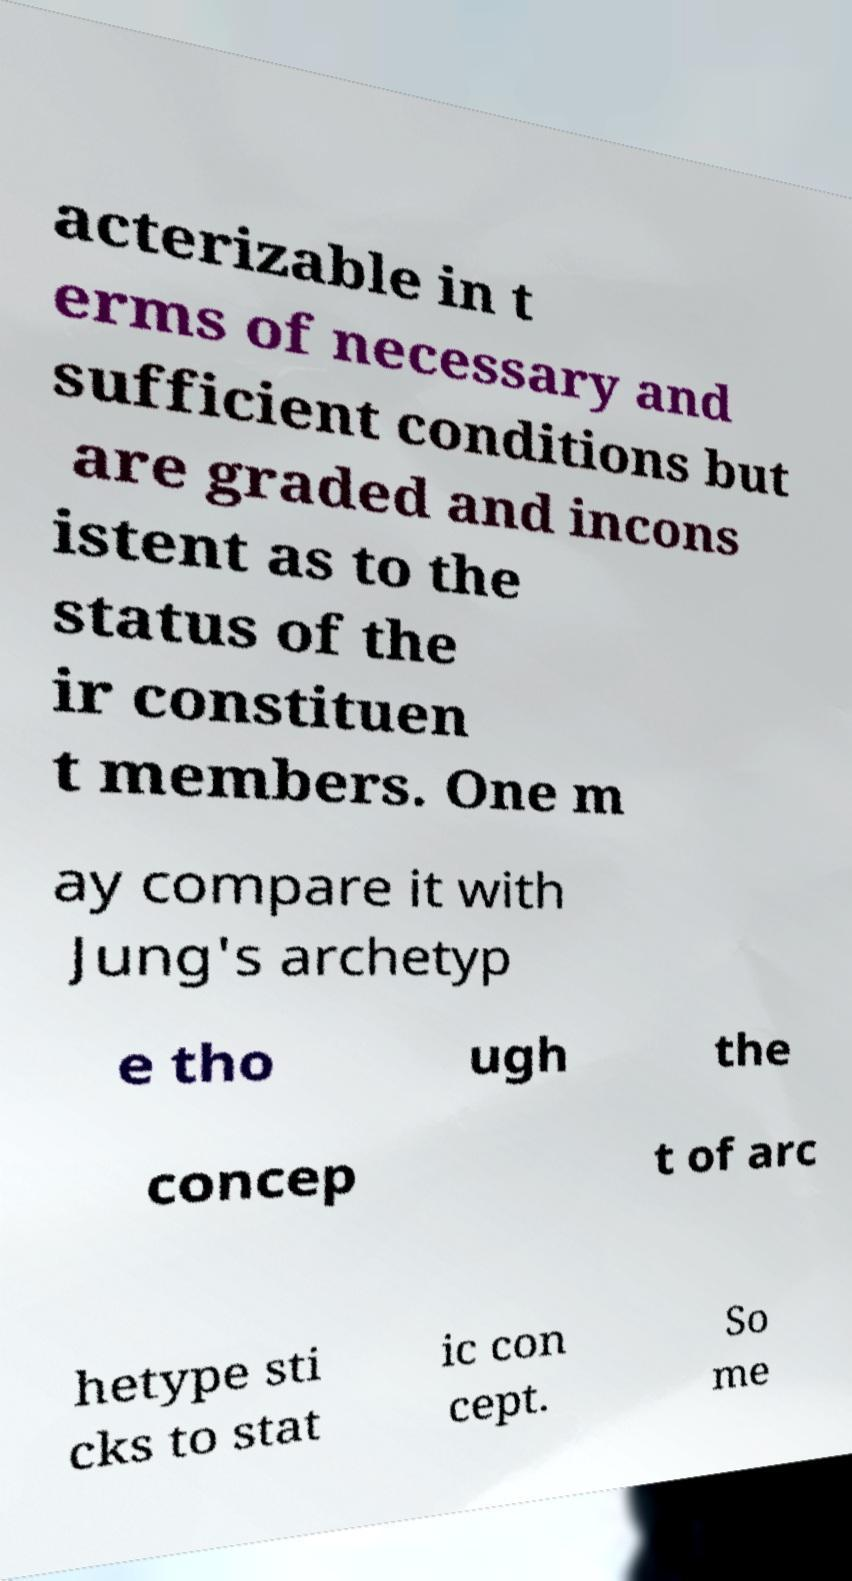What messages or text are displayed in this image? I need them in a readable, typed format. acterizable in t erms of necessary and sufficient conditions but are graded and incons istent as to the status of the ir constituen t members. One m ay compare it with Jung's archetyp e tho ugh the concep t of arc hetype sti cks to stat ic con cept. So me 